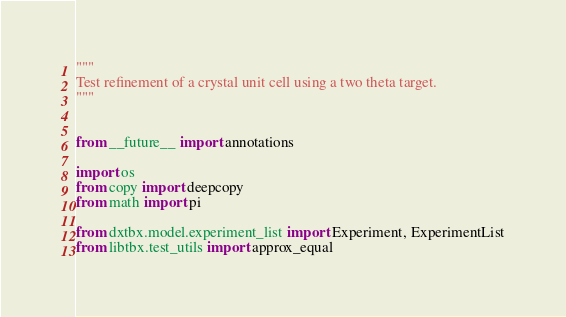<code> <loc_0><loc_0><loc_500><loc_500><_Python_>"""
Test refinement of a crystal unit cell using a two theta target.
"""


from __future__ import annotations

import os
from copy import deepcopy
from math import pi

from dxtbx.model.experiment_list import Experiment, ExperimentList
from libtbx.test_utils import approx_equal
</code> 